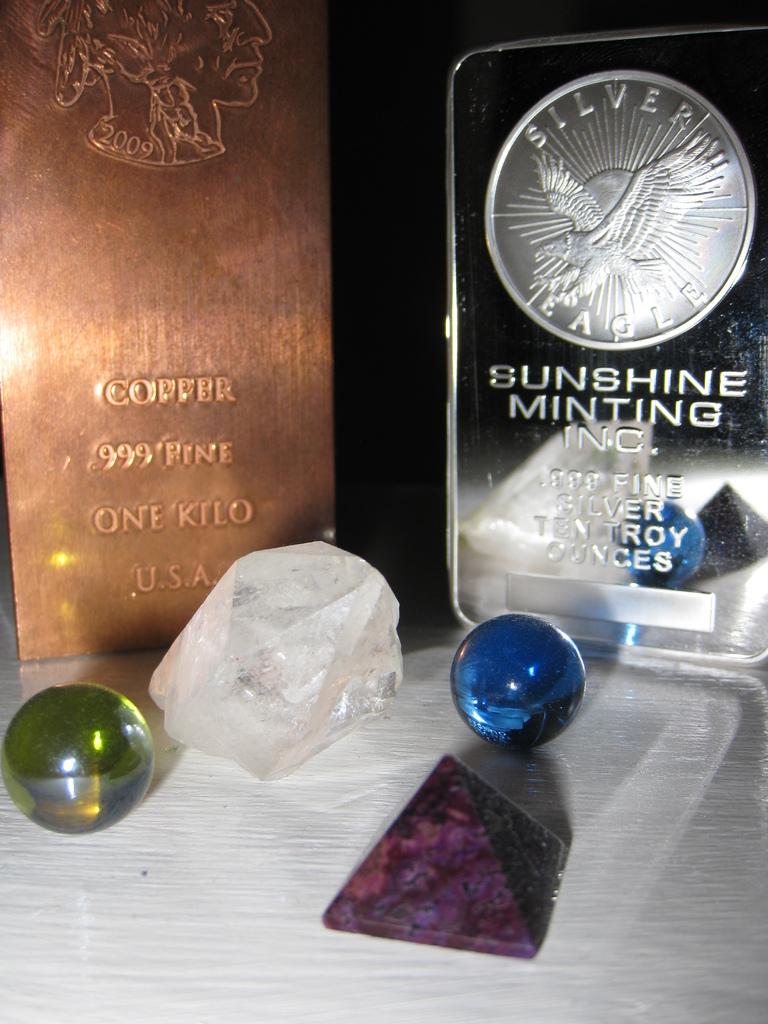What is the name of the minting company?
Your response must be concise. Sunshine minting inc. 